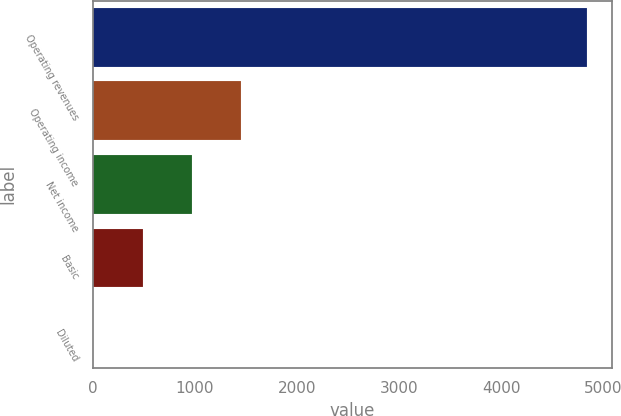<chart> <loc_0><loc_0><loc_500><loc_500><bar_chart><fcel>Operating revenues<fcel>Operating income<fcel>Net income<fcel>Basic<fcel>Diluted<nl><fcel>4846<fcel>1454.76<fcel>970.3<fcel>485.84<fcel>1.38<nl></chart> 